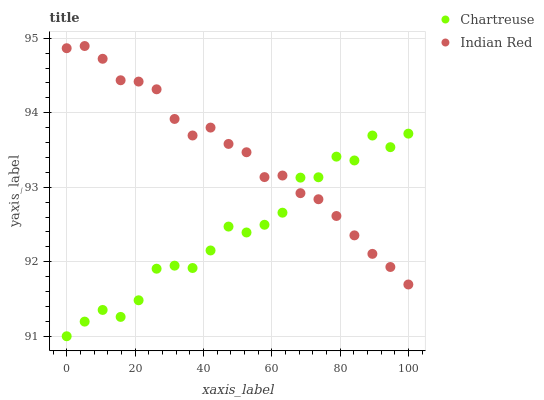Does Chartreuse have the minimum area under the curve?
Answer yes or no. Yes. Does Indian Red have the maximum area under the curve?
Answer yes or no. Yes. Does Indian Red have the minimum area under the curve?
Answer yes or no. No. Is Indian Red the smoothest?
Answer yes or no. Yes. Is Chartreuse the roughest?
Answer yes or no. Yes. Is Indian Red the roughest?
Answer yes or no. No. Does Chartreuse have the lowest value?
Answer yes or no. Yes. Does Indian Red have the lowest value?
Answer yes or no. No. Does Indian Red have the highest value?
Answer yes or no. Yes. Does Chartreuse intersect Indian Red?
Answer yes or no. Yes. Is Chartreuse less than Indian Red?
Answer yes or no. No. Is Chartreuse greater than Indian Red?
Answer yes or no. No. 